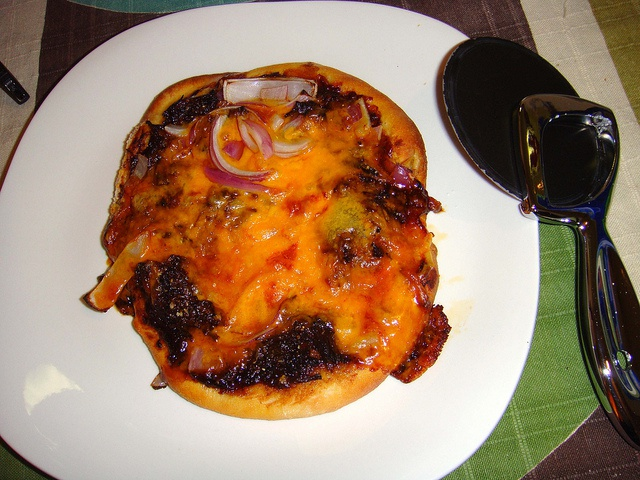Describe the objects in this image and their specific colors. I can see dining table in lightgray, maroon, black, and red tones and pizza in maroon and red tones in this image. 